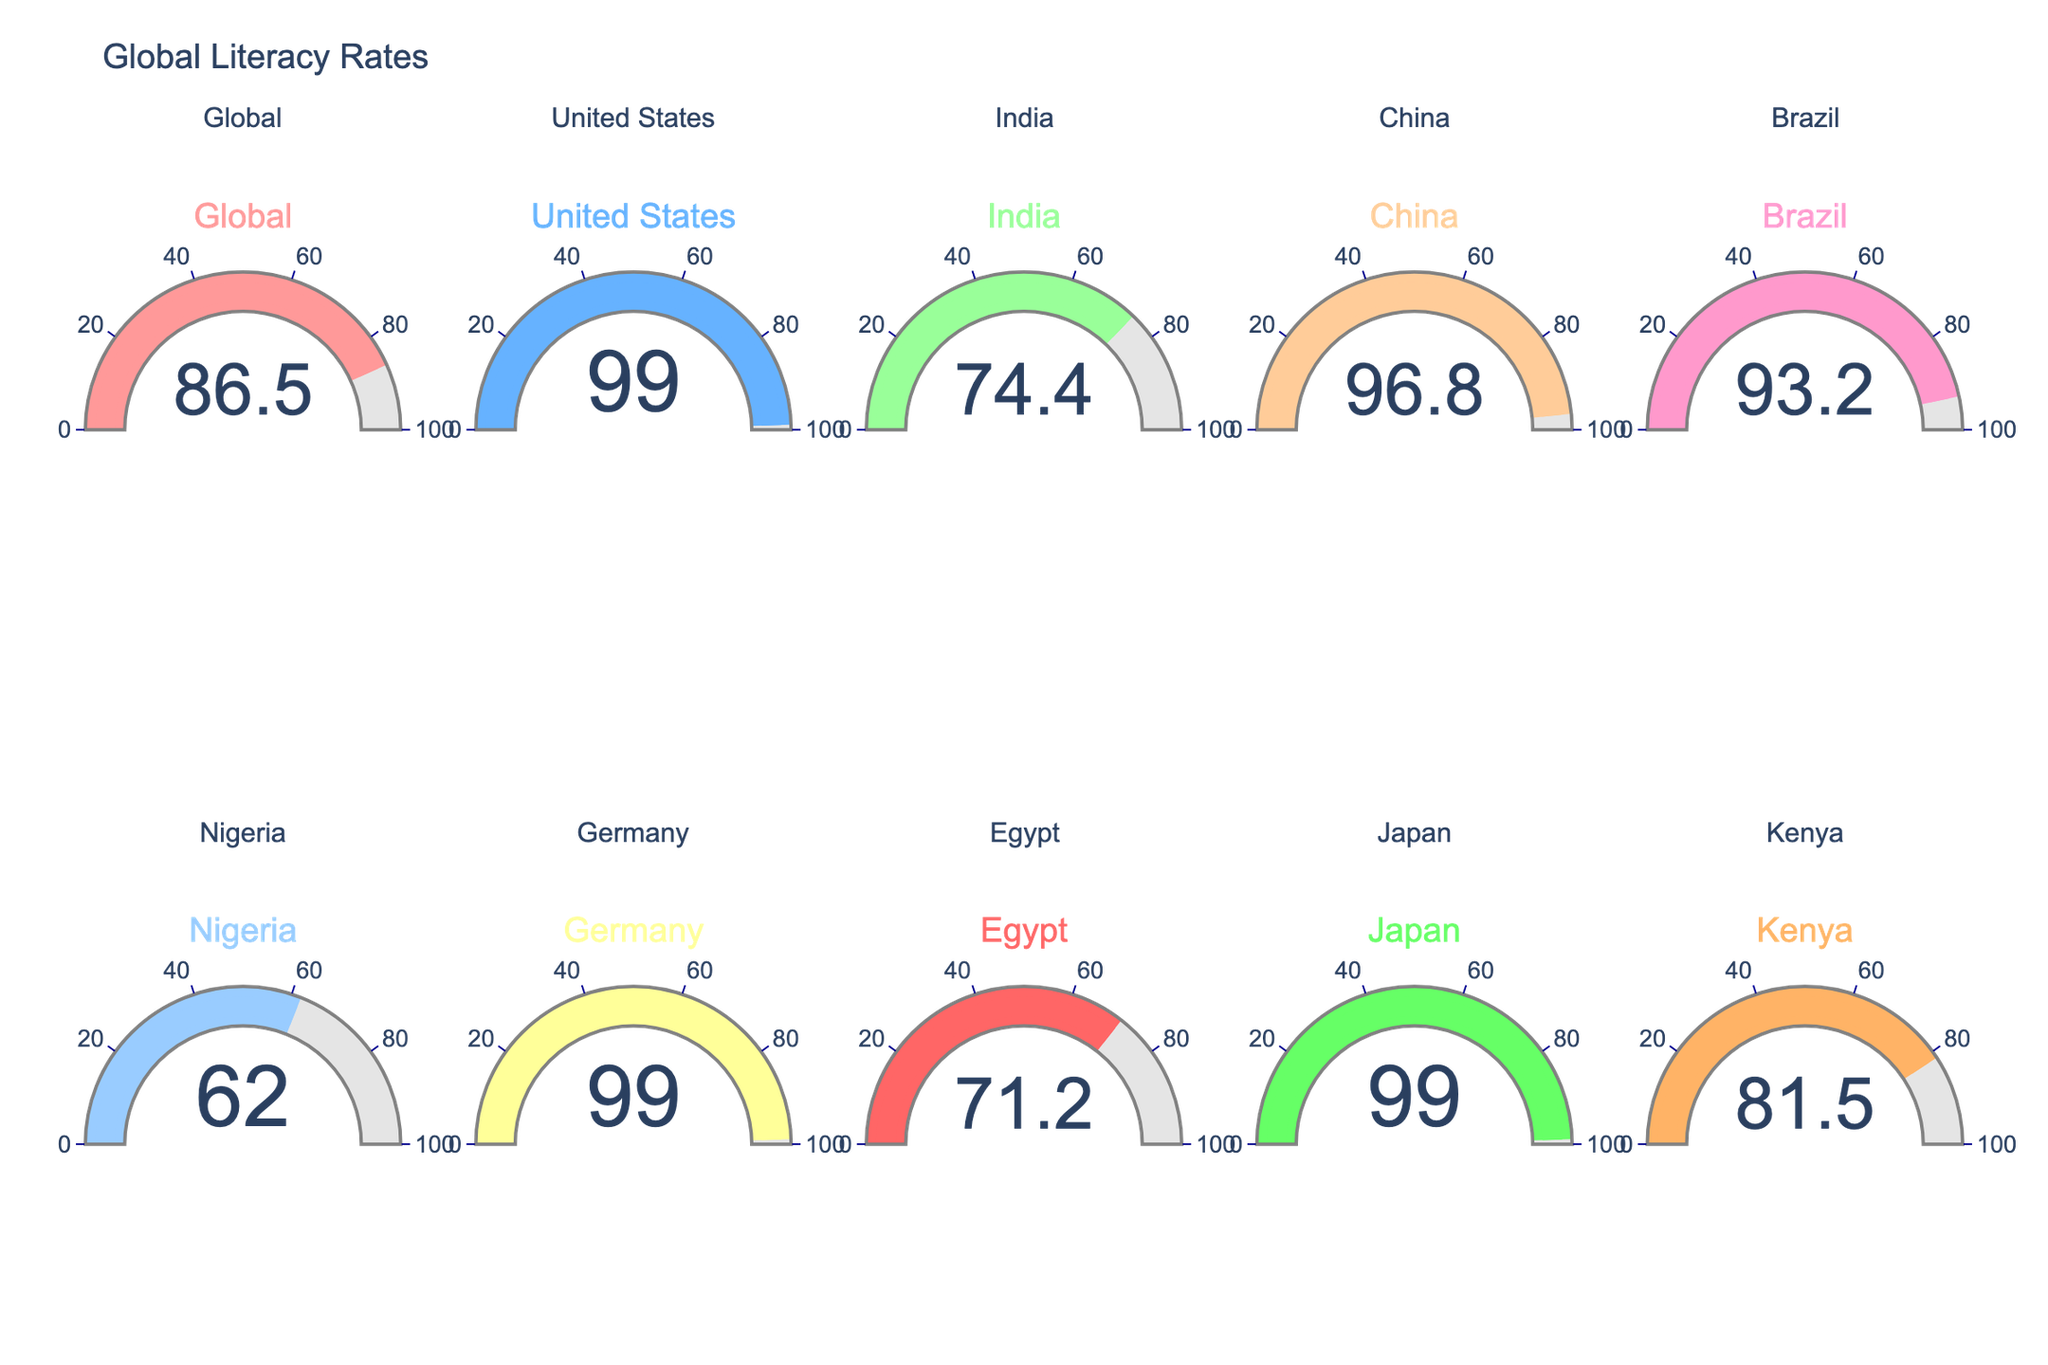What is the literacy rate of Nigeria? Look for the gauge chart labeled "Nigeria" and identify the indicated literacy rate, which is 62.0.
Answer: 62.0 Which country has the highest literacy rate? Check each country's literacy rate on their respective gauge chart. The highest rate is 99.0, which is shared by the United States, Germany, and Japan.
Answer: United States, Germany, Japan How does Brazil's literacy rate compare to India's literacy rate? Identify the literacy rates of Brazil (93.2) and India (74.4) from their respective gauge charts. Brazil's rate (93.2) is higher than India's rate (74.4).
Answer: Brazil's rate is higher What is the average literacy rate across all countries displayed? Sum the literacy rates and then divide by the number of countries. (86.5 + 99.0 + 74.4 + 96.8 + 93.2 + 62.0 + 99.0 + 71.2 + 99.0 + 81.5) / 10 = 86.36
Answer: 86.36 Which country has the lowest literacy rate? Find the smallest value among the literacy rates displayed. Nigeria has the lowest literacy rate, which is 62.0.
Answer: Nigeria How much higher is China’s literacy rate compared to Egypt's? Find China’s literacy rate (96.8) and Egypt's literacy rate (71.2). Subtract Egypt's rate from China's rate (96.8 - 71.2) to find the difference.
Answer: 25.6 What is the range of literacy rates represented in this chart? Identify the highest (99.0) and lowest values (62.0) and calculate the difference (99.0 - 62.0). The range is 37.0.
Answer: 37.0 How many countries have a literacy rate above the global average? The global literacy rate is 86.5. Count the countries with rates higher than 86.5: United States, China, Brazil, Germany, Japan. There are 5 countries.
Answer: 5 Is Kenya's literacy rate higher or lower than the global average? Compare Kenya's literacy rate (81.5) to the global rate (86.5). Since 81.5 is less than 86.5, Kenya's rate is lower.
Answer: Lower By how much does the literacy rate of Japan differ from the global literacy rate? Subtract the global literacy rate (86.5) from Japan's literacy rate (99.0) to find the difference (99.0 - 86.5).
Answer: 12.5 